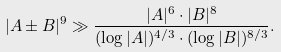<formula> <loc_0><loc_0><loc_500><loc_500>| A \pm B | ^ { 9 } \gg \frac { | A | ^ { 6 } \cdot | B | ^ { 8 } } { ( \log | A | ) ^ { 4 / 3 } \cdot ( \log | B | ) ^ { 8 / 3 } } .</formula> 